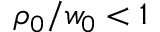Convert formula to latex. <formula><loc_0><loc_0><loc_500><loc_500>\rho _ { 0 } / w _ { 0 } < 1</formula> 